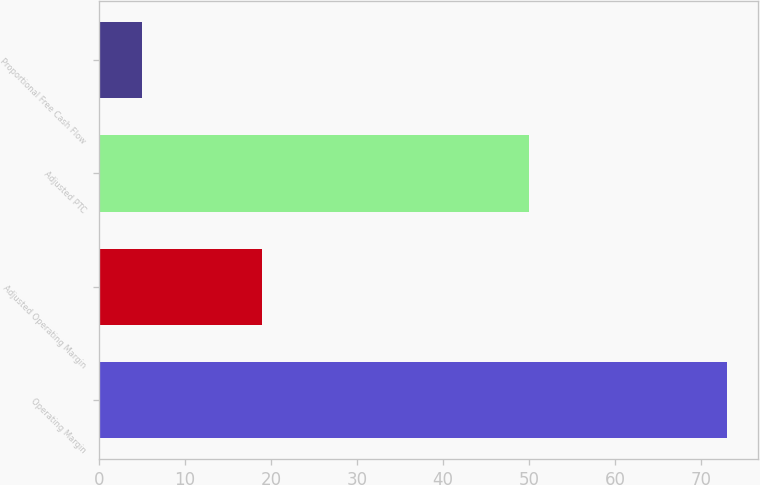<chart> <loc_0><loc_0><loc_500><loc_500><bar_chart><fcel>Operating Margin<fcel>Adjusted Operating Margin<fcel>Adjusted PTC<fcel>Proportional Free Cash Flow<nl><fcel>73<fcel>19<fcel>50<fcel>5<nl></chart> 